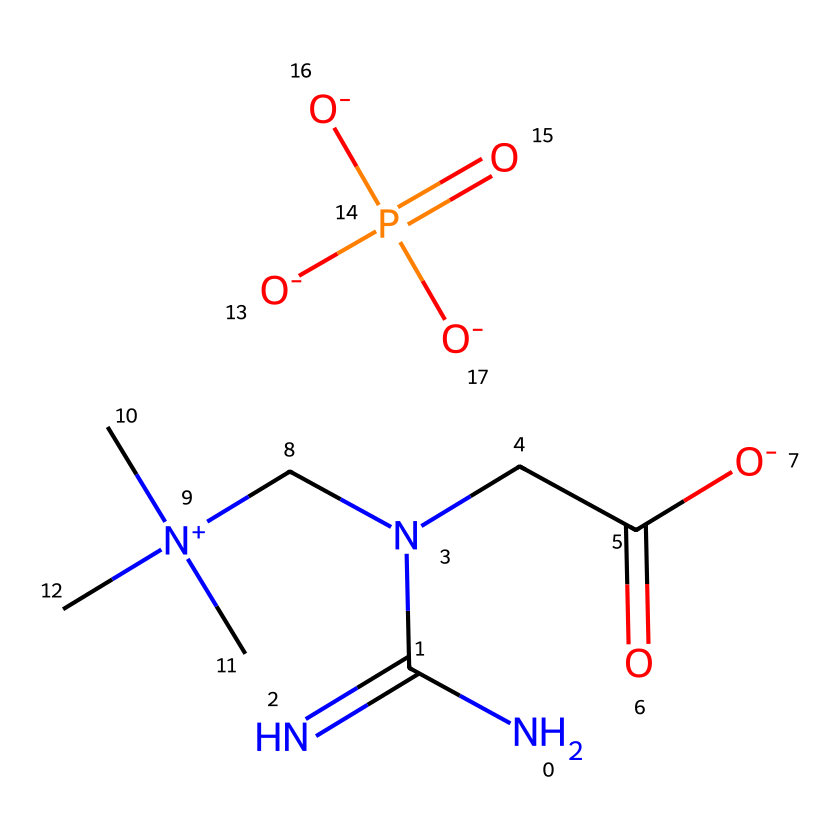What is the molecular formula of creatine phosphate? To determine the molecular formula, inspect the elements in the SMILES: nitrogen (N), carbon (C), oxygen (O), and phosphorus (P). Count the number of each atom; there are 6 carbons, 10 hydrogens, 2 nitrogens, 4 oxygens, and 1 phosphorus. So, the molecular formula is C6H14N2O4P.
Answer: C6H14N2O4P How many nitrogen atoms are present in this molecule? To count the nitrogen atoms, look at the SMILES representation. There are two instances of the element nitrogen (N); hence, the count is 2.
Answer: 2 What kind of functional groups are present in creatine phosphate? Analyze the SMILES for specific functional groups. The molecule contains a phosphate group (P(=O)([O-])[O-]) and a carboxyl group (CC(=O)[O-]). These represent its main functional components.
Answer: phosphate and carboxyl groups Which element in creatine phosphate is responsible for energy transfer? The phosphate group (P) is critical for energy transfer, as it plays a key role in ATP formation and muscle cell energy utilization. Look for the phosphorus atom in the structure that connects to multiple oxygen groups, indicating its role in energy processes.
Answer: phosphorus What is the total number of oxygen atoms in the molecule? Count the oxygen atoms in the SMILES. The phosphate group contributes three oxygen (O) atoms and the carboxyl group contributes one more, leading to a total of 4 oxygen atoms.
Answer: 4 What type of compound is creatine phosphate according to its structure? By analyzing the structure, particularly the phosphorus atom bonded to oxygen and carbon through amine groups, it can be identified as a phosphagen. The presence of both creatine structure and phosphate indicates its classification.
Answer: phosphagen 